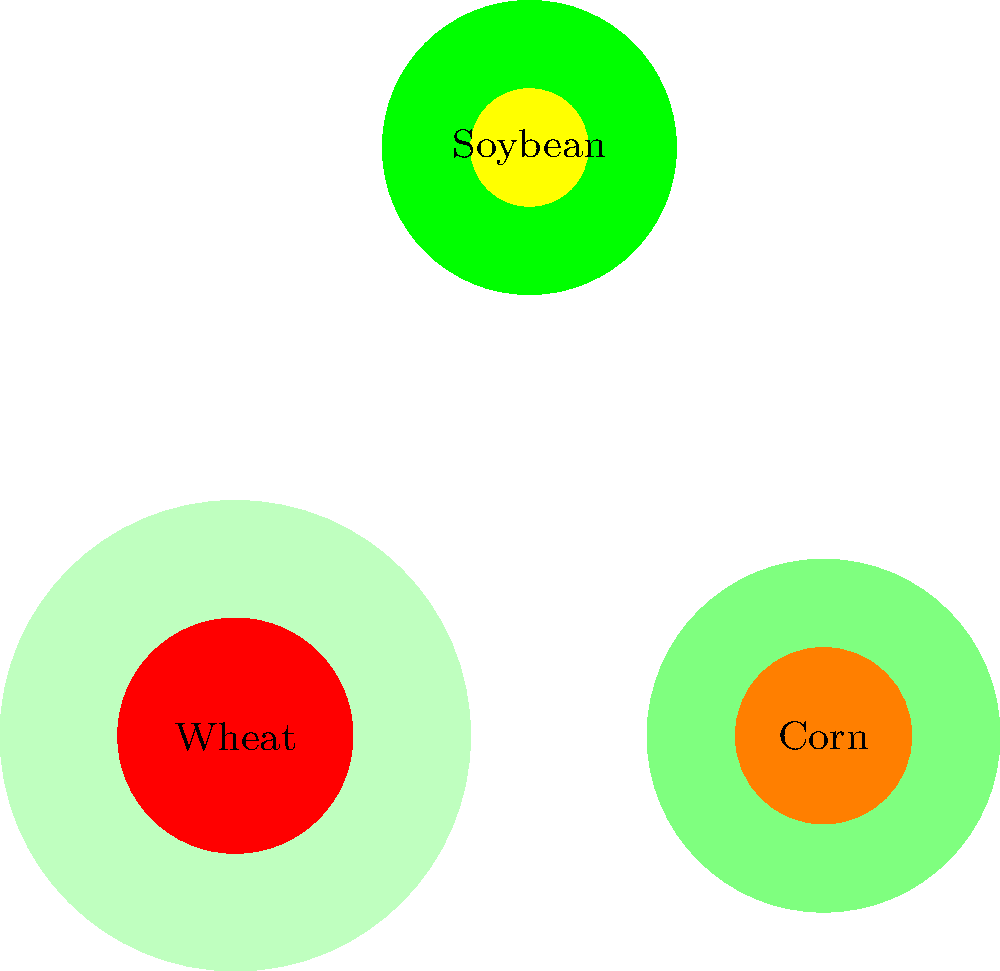Based on the aerial view of three crop fields shown above, which crop appears to have the most severe pest infestation in terms of affected area relative to total crop area? To determine which crop has the most severe pest infestation relative to its total area, we need to compare the ratio of infested area to total area for each crop:

1. Wheat (bottom left):
   - Total area: Large circle
   - Infested area: Medium-sized red circle
   - Ratio: Approximately 25% infested

2. Corn (bottom right):
   - Total area: Medium-sized circle
   - Infested area: Small orange circle
   - Ratio: Approximately 25% infested

3. Soybean (top center):
   - Total area: Small circle
   - Infested area: Very small yellow circle
   - Ratio: Approximately 16% infested

Comparing these ratios, we can see that both wheat and corn have similar infestation ratios of about 25%, while soybeans have a lower ratio of about 16%. Therefore, wheat and corn are equally affected and more severely infested than soybeans relative to their total areas.
Answer: Wheat and Corn (equally) 